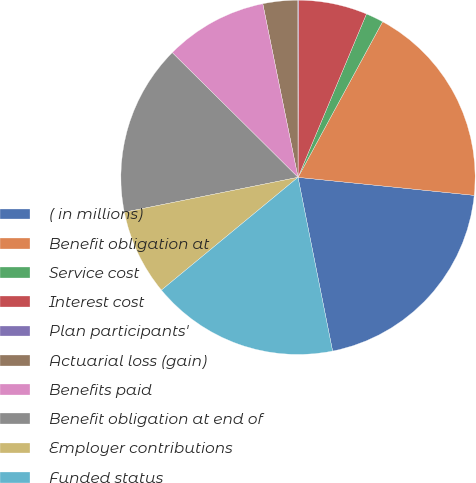Convert chart to OTSL. <chart><loc_0><loc_0><loc_500><loc_500><pie_chart><fcel>( in millions)<fcel>Benefit obligation at<fcel>Service cost<fcel>Interest cost<fcel>Plan participants'<fcel>Actuarial loss (gain)<fcel>Benefits paid<fcel>Benefit obligation at end of<fcel>Employer contributions<fcel>Funded status<nl><fcel>20.25%<fcel>18.7%<fcel>1.61%<fcel>6.27%<fcel>0.06%<fcel>3.17%<fcel>9.38%<fcel>15.59%<fcel>7.83%<fcel>17.14%<nl></chart> 